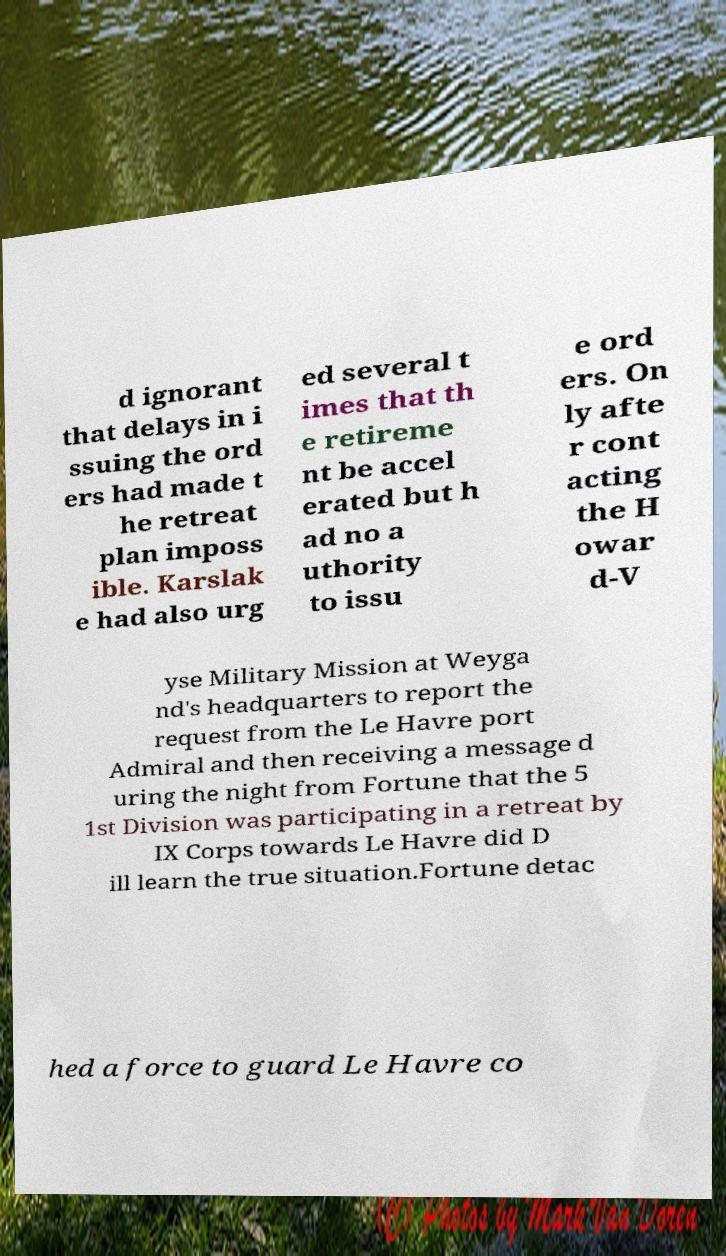For documentation purposes, I need the text within this image transcribed. Could you provide that? d ignorant that delays in i ssuing the ord ers had made t he retreat plan imposs ible. Karslak e had also urg ed several t imes that th e retireme nt be accel erated but h ad no a uthority to issu e ord ers. On ly afte r cont acting the H owar d-V yse Military Mission at Weyga nd's headquarters to report the request from the Le Havre port Admiral and then receiving a message d uring the night from Fortune that the 5 1st Division was participating in a retreat by IX Corps towards Le Havre did D ill learn the true situation.Fortune detac hed a force to guard Le Havre co 